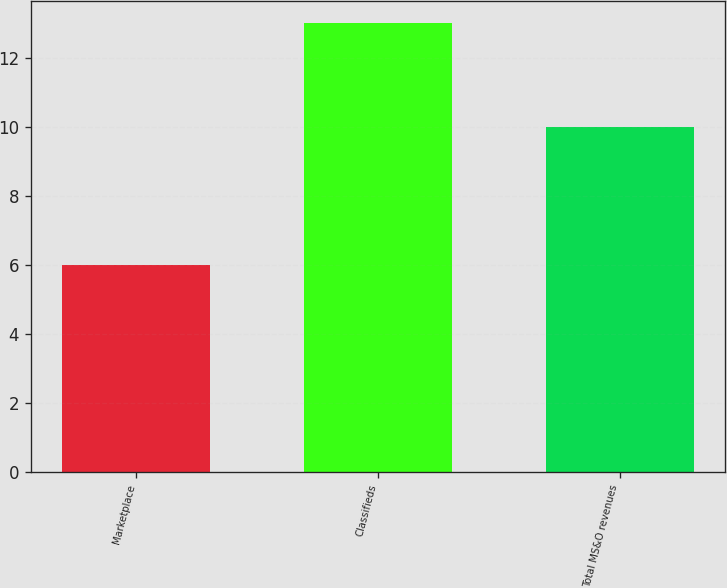<chart> <loc_0><loc_0><loc_500><loc_500><bar_chart><fcel>Marketplace<fcel>Classifieds<fcel>Total MS&O revenues<nl><fcel>6<fcel>13<fcel>10<nl></chart> 